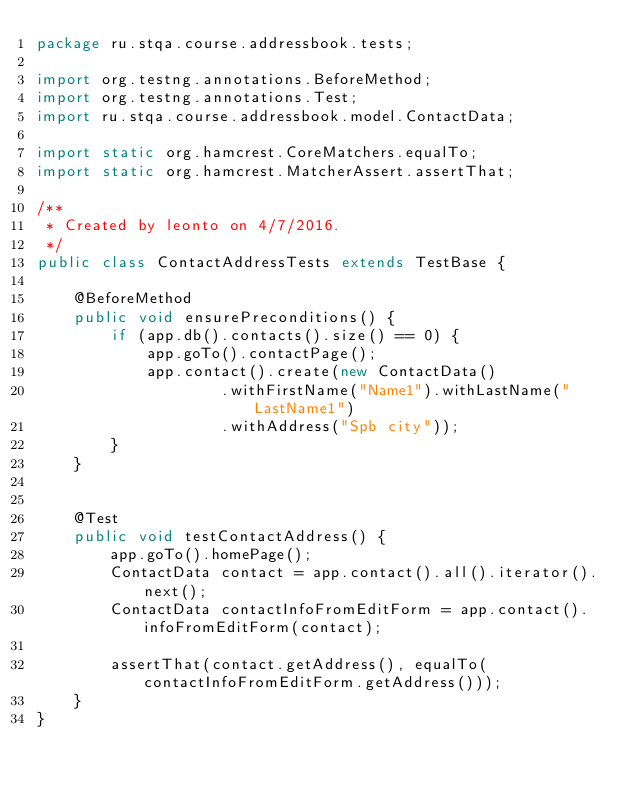Convert code to text. <code><loc_0><loc_0><loc_500><loc_500><_Java_>package ru.stqa.course.addressbook.tests;

import org.testng.annotations.BeforeMethod;
import org.testng.annotations.Test;
import ru.stqa.course.addressbook.model.ContactData;

import static org.hamcrest.CoreMatchers.equalTo;
import static org.hamcrest.MatcherAssert.assertThat;

/**
 * Created by leonto on 4/7/2016.
 */
public class ContactAddressTests extends TestBase {

    @BeforeMethod
    public void ensurePreconditions() {
        if (app.db().contacts().size() == 0) {
            app.goTo().contactPage();
            app.contact().create(new ContactData()
                    .withFirstName("Name1").withLastName("LastName1")
                    .withAddress("Spb city"));
        }
    }


    @Test
    public void testContactAddress() {
        app.goTo().homePage();
        ContactData contact = app.contact().all().iterator().next();
        ContactData contactInfoFromEditForm = app.contact().infoFromEditForm(contact);

        assertThat(contact.getAddress(), equalTo(contactInfoFromEditForm.getAddress()));
    }
}
</code> 